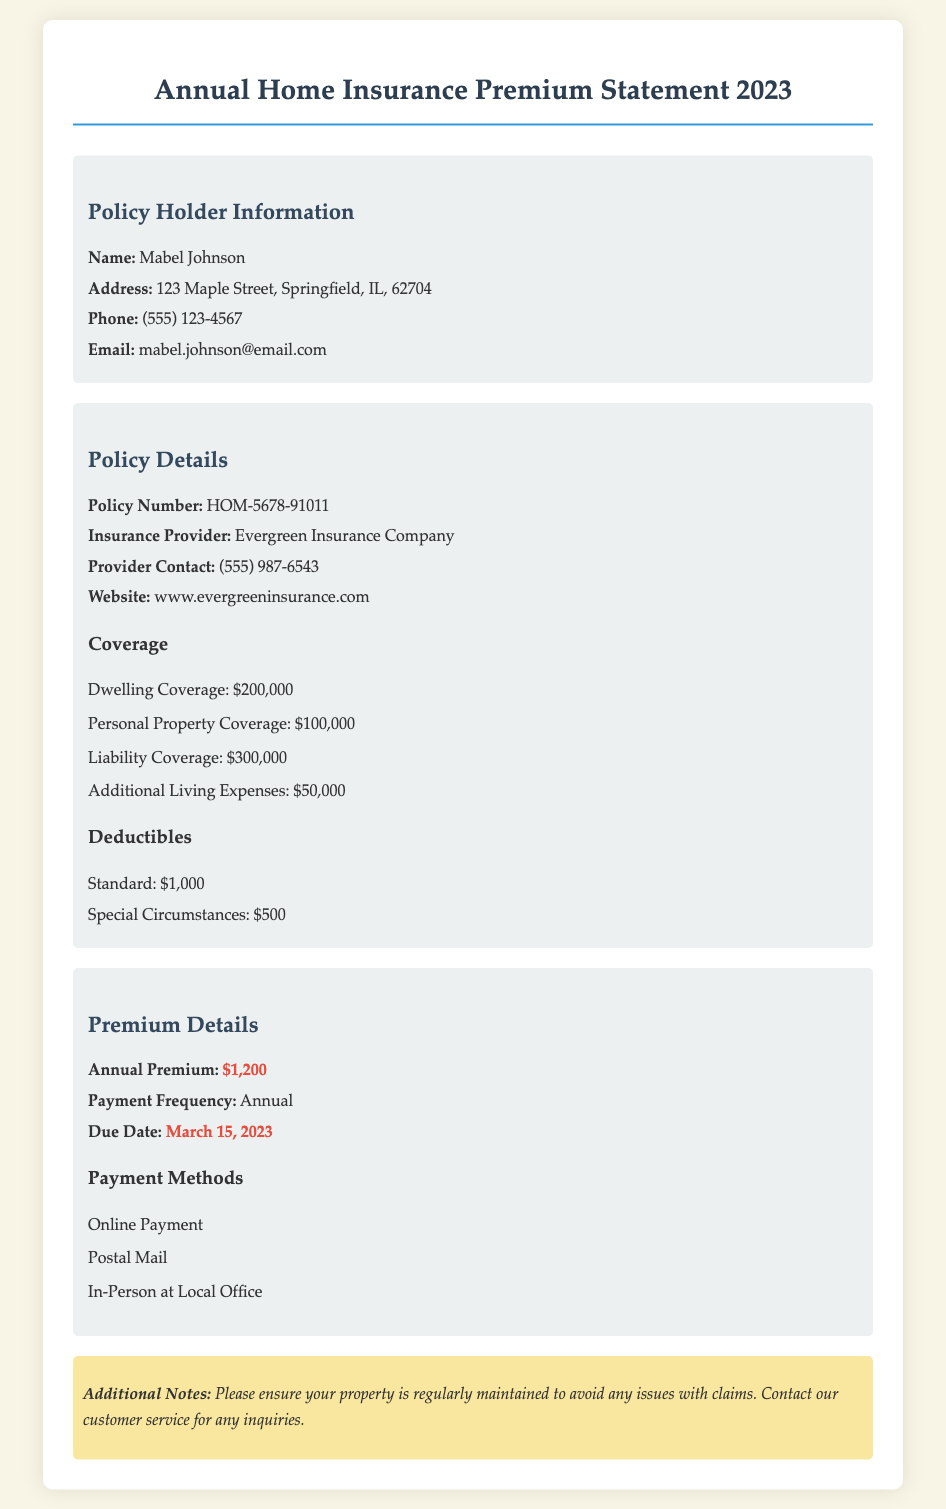What is the policy number? The policy number is found in the policy details section of the document, which states that it is HOM-5678-91011.
Answer: HOM-5678-91011 Who is the insurance provider? The insurance provider is mentioned in the policy details, which states that it is Evergreen Insurance Company.
Answer: Evergreen Insurance Company What is the annual premium amount? The annual premium amount is highlighted in the premium details section as $1,200.
Answer: $1,200 When is the payment due date? The payment due date is found in the premium details section, which specifies it as March 15, 2023.
Answer: March 15, 2023 What type of coverage is included under liability? Liability coverage is detailed in the coverage section, which indicates it is $300,000.
Answer: $300,000 What are the deductibles for standard circumstances? The standard deductible is specified in the document as $1,000 in the deductibles section.
Answer: $1,000 How many payment methods are listed? The payment methods section lists three different ways to pay, including online, postal mail, and in-person.
Answer: Three Who should be contacted for inquiries? The document mentions to contact customer service for any inquiries.
Answer: Customer service What is the address of the policy holder? The policy holder's address is provided in the policy holder information section as 123 Maple Street, Springfield, IL, 62704.
Answer: 123 Maple Street, Springfield, IL, 62704 